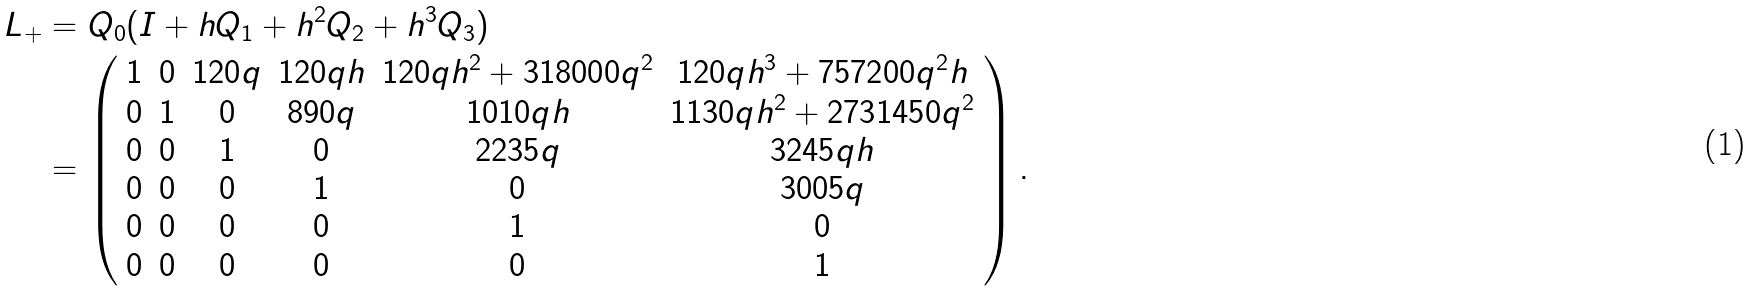<formula> <loc_0><loc_0><loc_500><loc_500>L _ { + } & = Q _ { 0 } ( I + h Q _ { 1 } + h ^ { 2 } Q _ { 2 } + h ^ { 3 } Q _ { 3 } ) \\ & = \left ( \begin{array} { c c c c c c } 1 & 0 & 1 2 0 q & 1 2 0 q h & 1 2 0 q h ^ { 2 } + 3 1 8 0 0 0 q ^ { 2 } & 1 2 0 q h ^ { 3 } + 7 5 7 2 0 0 q ^ { 2 } h \\ 0 & 1 & 0 & 8 9 0 q & 1 0 1 0 q h & 1 1 3 0 q h ^ { 2 } + 2 7 3 1 4 5 0 q ^ { 2 } \\ 0 & 0 & 1 & 0 & 2 2 3 5 q & 3 2 4 5 q h \\ 0 & 0 & 0 & 1 & 0 & 3 0 0 5 q \\ 0 & 0 & 0 & 0 & 1 & 0 \\ 0 & 0 & 0 & 0 & 0 & 1 \\ \end{array} \right ) .</formula> 